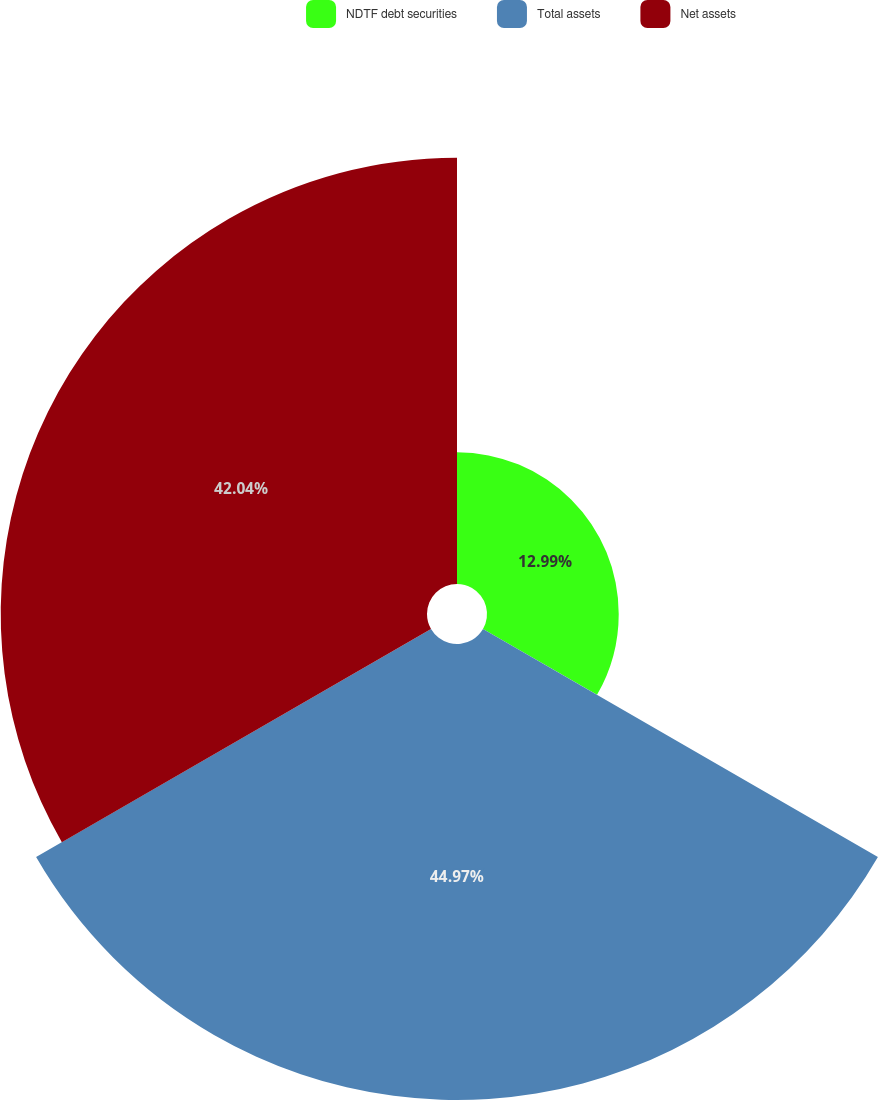<chart> <loc_0><loc_0><loc_500><loc_500><pie_chart><fcel>NDTF debt securities<fcel>Total assets<fcel>Net assets<nl><fcel>12.99%<fcel>44.97%<fcel>42.04%<nl></chart> 